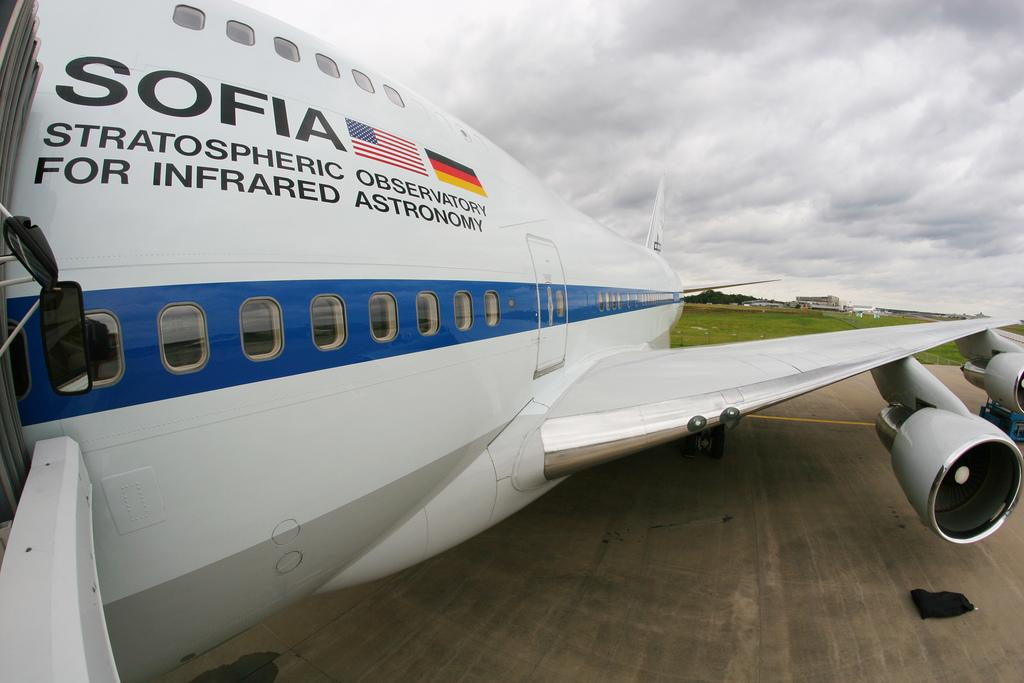<image>
Present a compact description of the photo's key features. An airplane is owned by SOFIA, the Stratospheric Observatory for Infrared Astronomy. 